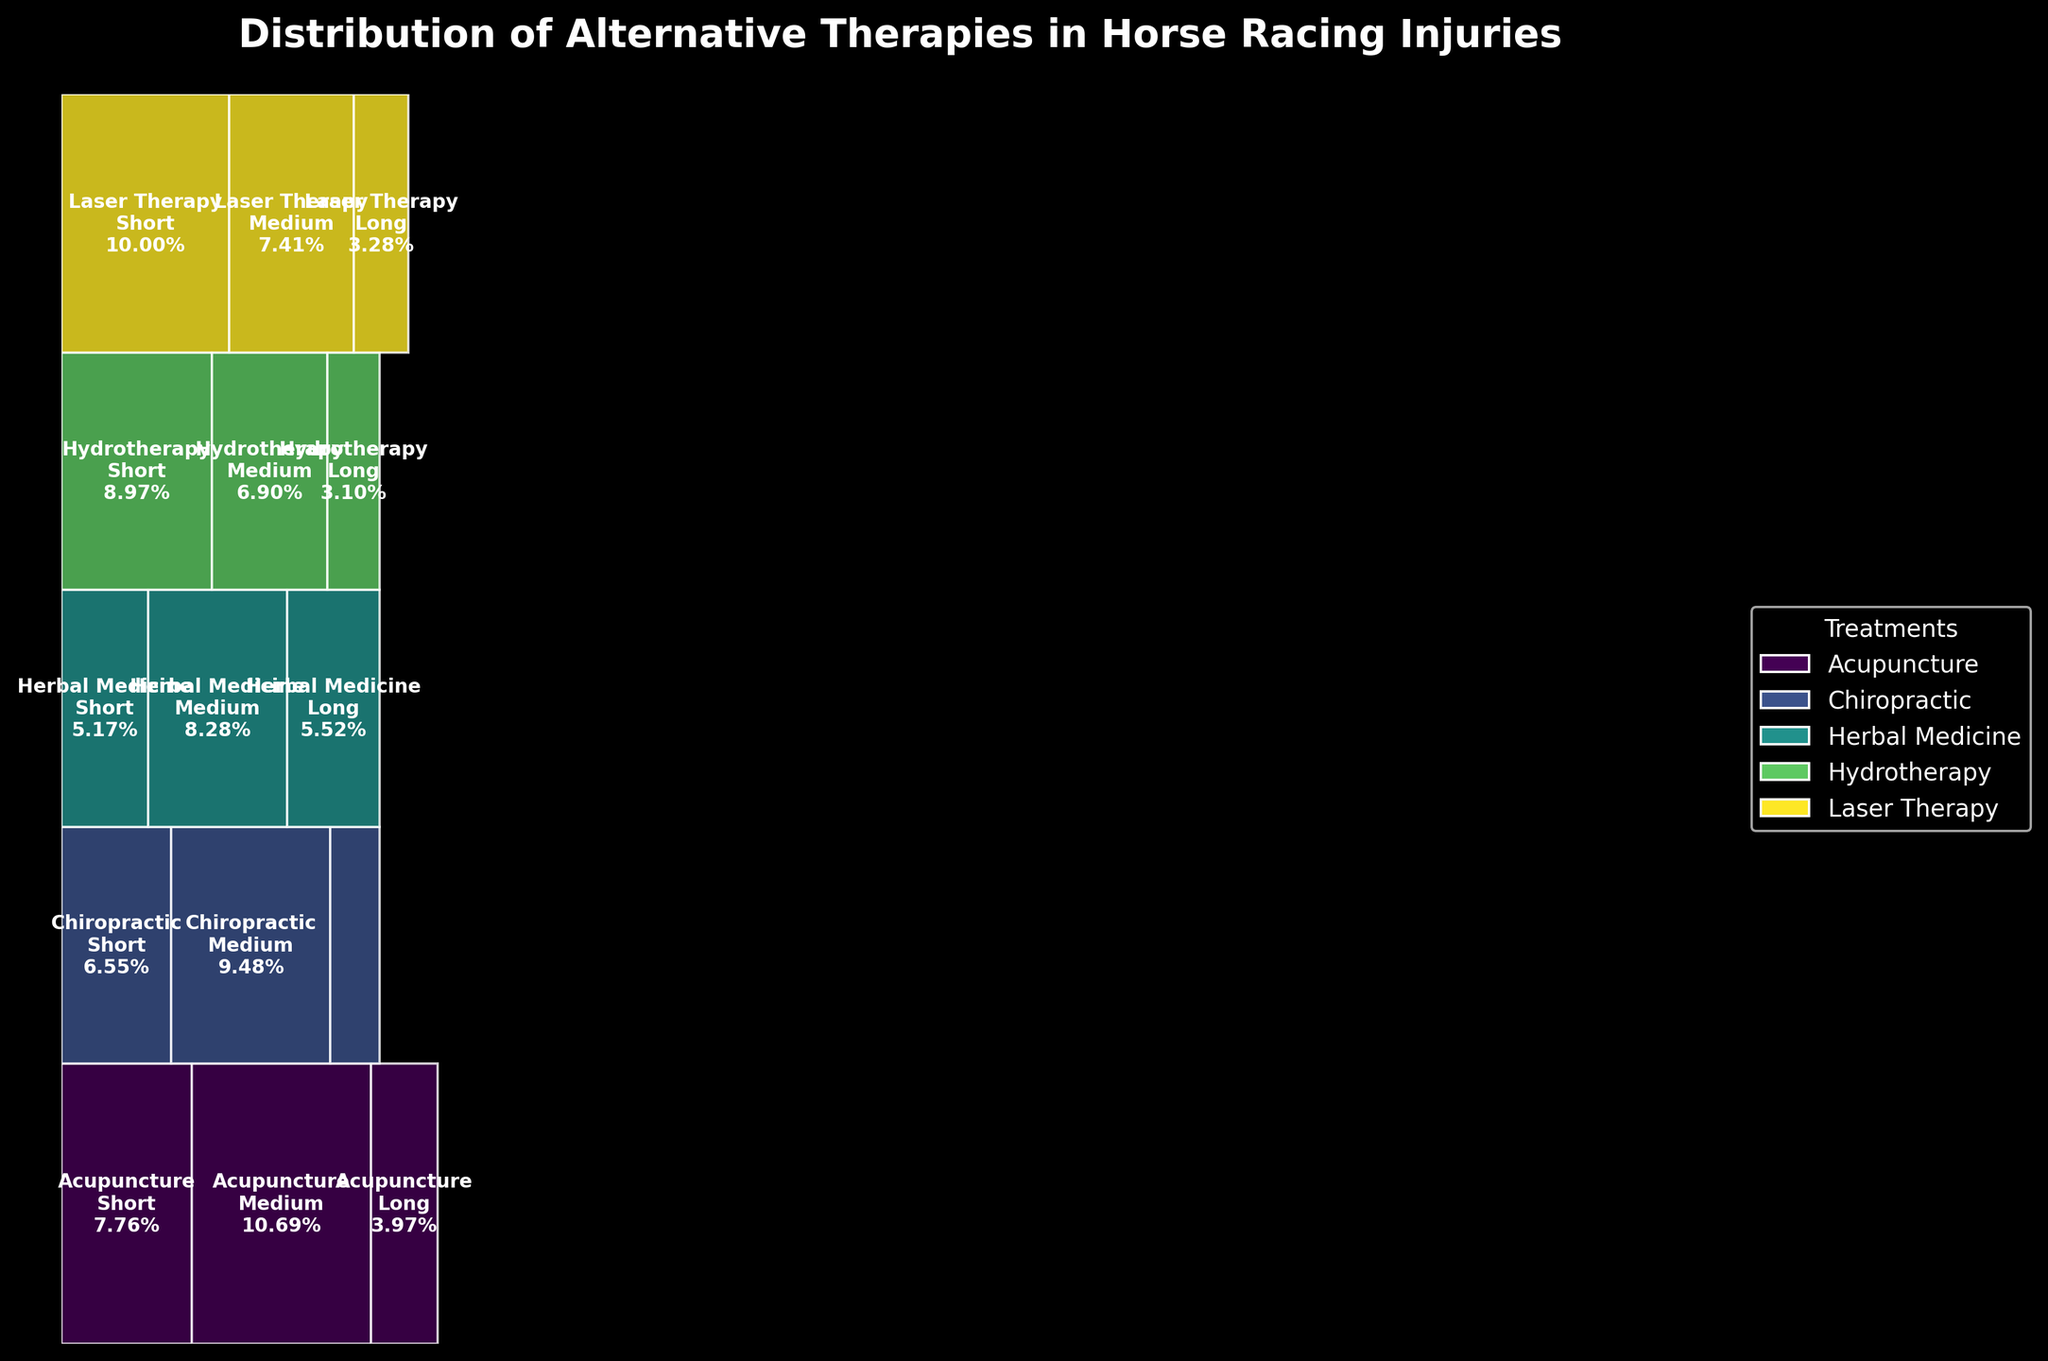What is the title of the figure? The title typically appears at the top of the figure. Here, it is "Distribution of Alternative Therapies in Horse Racing Injuries".
Answer: Distribution of Alternative Therapies in Horse Racing Injuries How many types of treatments are represented in the plot? By looking at the legend and analyzing the different color patches, we can count the number of unique treatments represented. The treatments are Acupuncture, Chiropractic, Herbal Medicine, Hydrotherapy, and Laser Therapy.
Answer: 5 Which recovery time period has the highest proportion for Laser Therapy? By examining the size of the rectangles corresponding to Laser Therapy, the largest rectangle will have the highest proportion. In this case, the "Short" recovery time period has the highest proportion.
Answer: Short Which treatment has the largest total representation across all recovery times? We need to compare the total heights of all treatments. The treatment with the largest rectangle height will have the largest total representation. It is Laser Therapy.
Answer: Laser Therapy What is the combined proportion of Acupuncture and Chiropractic for the short recovery time? Identify the widths of the rectangles for Acupuncture and Chiropractic for the short recovery time, and sum them up. 45 (Acupuncture, Short) and 38 (Chiropractic, Short). Sum the counts and divide by total counts: (45+38)/507 ≈ 16.40%.
Answer: Approximately 16.40% What treatment has the smallest proportion for the long recovery time? By examining the heights and widths of rectangles representing each treatment for the long recovery time, find the smallest one. This is Chiropractic.
Answer: Chiropractic Which two treatments have the closest proportions for medium recovery time? Compare the rectangle widths for all treatments with medium recovery time. Laser Therapy (43) and Chiropractic (55) are closest.
Answer: Laser Therapy and Chiropractic What proportion of total treatments does Hydrotherapy account for? Sum the segments representing Hydrotherapy across all recovery times and divide by the total count. Hydrotherapy counts are (52+40+18) totaling 110. Total counts across all treatments are 507. Therefore, 110/507 ≈ 21.69%.
Answer: Approximately 21.69% How does the proportion of Herbal Medicine for long recovery time compare to that of Hydrotherapy for medium recovery time? Check the rectangle widths for Herbal Medicine (32) in the long recovery time and Hydrotherapy (40) in the medium recovery time; 32/507 ≈ 6.31% and 40/507 ≈ 7.89%.
Answer: Herbal Medicine is less than Hydrotherapy What's the common characteristic shared by the largest segments of each treatment? Analyze the rectangles across all treatments and note the pattern in the largest segments. Most treatments have the largest proportion of their counts in the short recovery time period.
Answer: Short recovery time 